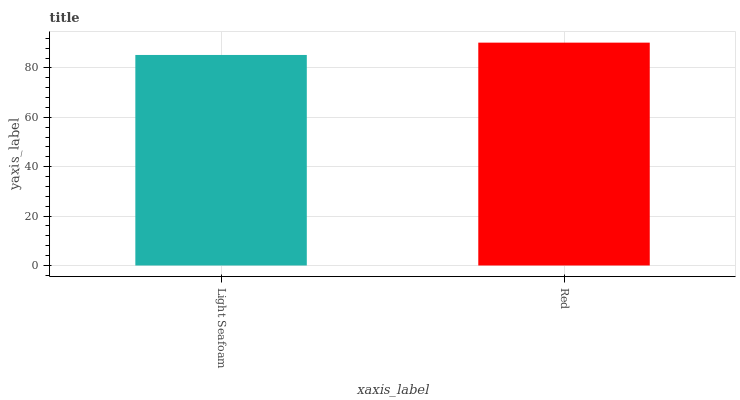Is Light Seafoam the minimum?
Answer yes or no. Yes. Is Red the maximum?
Answer yes or no. Yes. Is Red the minimum?
Answer yes or no. No. Is Red greater than Light Seafoam?
Answer yes or no. Yes. Is Light Seafoam less than Red?
Answer yes or no. Yes. Is Light Seafoam greater than Red?
Answer yes or no. No. Is Red less than Light Seafoam?
Answer yes or no. No. Is Red the high median?
Answer yes or no. Yes. Is Light Seafoam the low median?
Answer yes or no. Yes. Is Light Seafoam the high median?
Answer yes or no. No. Is Red the low median?
Answer yes or no. No. 